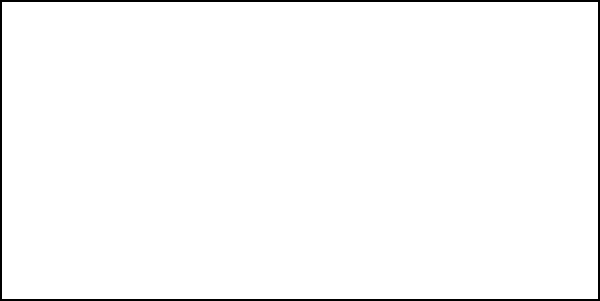In a crucial save during a game against the Chicago Blackhawks, you observe the goalie's hip joint angle changing from $\theta_1$ to $\theta_2$ as shown in the diagram. If the angular velocity of this movement is 5 rad/s and the moment of inertia of the goalie's leg about the hip joint is 3 kg⋅m², what is the angular momentum of the goalie's leg during this save movement? To solve this problem, we'll follow these steps:

1. Recall the formula for angular momentum:
   $L = I\omega$
   Where:
   $L$ = angular momentum
   $I$ = moment of inertia
   $\omega$ = angular velocity

2. We are given:
   $I = 3$ kg⋅m²
   $\omega = 5$ rad/s

3. Now, let's substitute these values into the formula:
   $L = I\omega$
   $L = (3 \text{ kg⋅m²}) \times (5 \text{ rad/s})$

4. Perform the calculation:
   $L = 15 \text{ kg⋅m²/s}$

5. The units kg⋅m²/s are equivalent to J⋅s (Joule-seconds), which are the standard units for angular momentum.

Therefore, the angular momentum of the goalie's leg during this save movement is 15 J⋅s.
Answer: 15 J⋅s 